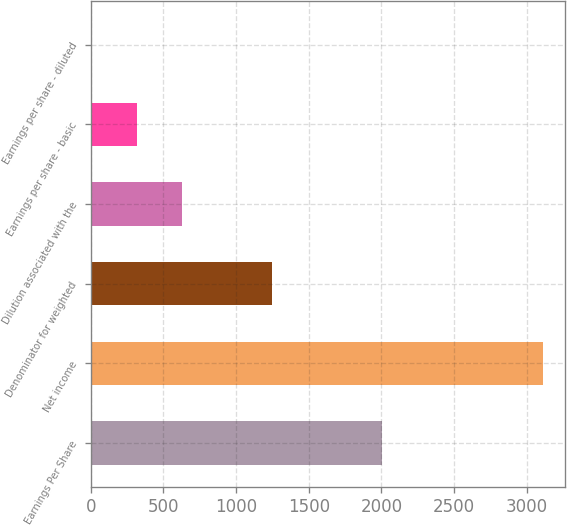Convert chart. <chart><loc_0><loc_0><loc_500><loc_500><bar_chart><fcel>Earnings Per Share<fcel>Net income<fcel>Denominator for weighted<fcel>Dilution associated with the<fcel>Earnings per share - basic<fcel>Earnings per share - diluted<nl><fcel>2005<fcel>3111<fcel>1246.78<fcel>625.38<fcel>314.68<fcel>3.98<nl></chart> 